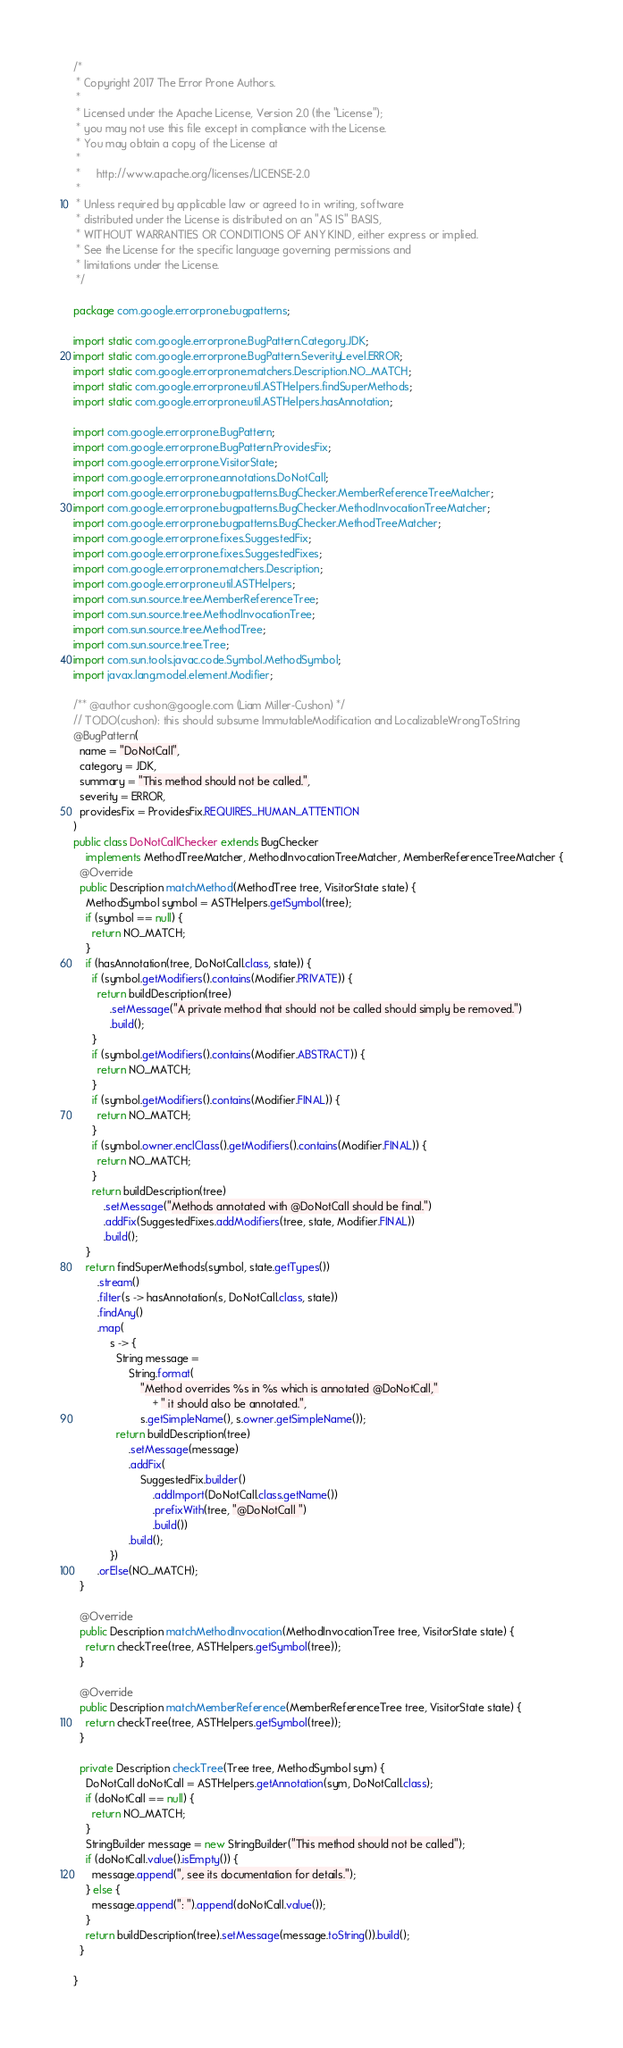Convert code to text. <code><loc_0><loc_0><loc_500><loc_500><_Java_>/*
 * Copyright 2017 The Error Prone Authors.
 *
 * Licensed under the Apache License, Version 2.0 (the "License");
 * you may not use this file except in compliance with the License.
 * You may obtain a copy of the License at
 *
 *     http://www.apache.org/licenses/LICENSE-2.0
 *
 * Unless required by applicable law or agreed to in writing, software
 * distributed under the License is distributed on an "AS IS" BASIS,
 * WITHOUT WARRANTIES OR CONDITIONS OF ANY KIND, either express or implied.
 * See the License for the specific language governing permissions and
 * limitations under the License.
 */

package com.google.errorprone.bugpatterns;

import static com.google.errorprone.BugPattern.Category.JDK;
import static com.google.errorprone.BugPattern.SeverityLevel.ERROR;
import static com.google.errorprone.matchers.Description.NO_MATCH;
import static com.google.errorprone.util.ASTHelpers.findSuperMethods;
import static com.google.errorprone.util.ASTHelpers.hasAnnotation;

import com.google.errorprone.BugPattern;
import com.google.errorprone.BugPattern.ProvidesFix;
import com.google.errorprone.VisitorState;
import com.google.errorprone.annotations.DoNotCall;
import com.google.errorprone.bugpatterns.BugChecker.MemberReferenceTreeMatcher;
import com.google.errorprone.bugpatterns.BugChecker.MethodInvocationTreeMatcher;
import com.google.errorprone.bugpatterns.BugChecker.MethodTreeMatcher;
import com.google.errorprone.fixes.SuggestedFix;
import com.google.errorprone.fixes.SuggestedFixes;
import com.google.errorprone.matchers.Description;
import com.google.errorprone.util.ASTHelpers;
import com.sun.source.tree.MemberReferenceTree;
import com.sun.source.tree.MethodInvocationTree;
import com.sun.source.tree.MethodTree;
import com.sun.source.tree.Tree;
import com.sun.tools.javac.code.Symbol.MethodSymbol;
import javax.lang.model.element.Modifier;

/** @author cushon@google.com (Liam Miller-Cushon) */
// TODO(cushon): this should subsume ImmutableModification and LocalizableWrongToString
@BugPattern(
  name = "DoNotCall",
  category = JDK,
  summary = "This method should not be called.",
  severity = ERROR,
  providesFix = ProvidesFix.REQUIRES_HUMAN_ATTENTION
)
public class DoNotCallChecker extends BugChecker
    implements MethodTreeMatcher, MethodInvocationTreeMatcher, MemberReferenceTreeMatcher {
  @Override
  public Description matchMethod(MethodTree tree, VisitorState state) {
    MethodSymbol symbol = ASTHelpers.getSymbol(tree);
    if (symbol == null) {
      return NO_MATCH;
    }
    if (hasAnnotation(tree, DoNotCall.class, state)) {
      if (symbol.getModifiers().contains(Modifier.PRIVATE)) {
        return buildDescription(tree)
            .setMessage("A private method that should not be called should simply be removed.")
            .build();
      }
      if (symbol.getModifiers().contains(Modifier.ABSTRACT)) {
        return NO_MATCH;
      }
      if (symbol.getModifiers().contains(Modifier.FINAL)) {
        return NO_MATCH;
      }
      if (symbol.owner.enclClass().getModifiers().contains(Modifier.FINAL)) {
        return NO_MATCH;
      }
      return buildDescription(tree)
          .setMessage("Methods annotated with @DoNotCall should be final.")
          .addFix(SuggestedFixes.addModifiers(tree, state, Modifier.FINAL))
          .build();
    }
    return findSuperMethods(symbol, state.getTypes())
        .stream()
        .filter(s -> hasAnnotation(s, DoNotCall.class, state))
        .findAny()
        .map(
            s -> {
              String message =
                  String.format(
                      "Method overrides %s in %s which is annotated @DoNotCall,"
                          + " it should also be annotated.",
                      s.getSimpleName(), s.owner.getSimpleName());
              return buildDescription(tree)
                  .setMessage(message)
                  .addFix(
                      SuggestedFix.builder()
                          .addImport(DoNotCall.class.getName())
                          .prefixWith(tree, "@DoNotCall ")
                          .build())
                  .build();
            })
        .orElse(NO_MATCH);
  }

  @Override
  public Description matchMethodInvocation(MethodInvocationTree tree, VisitorState state) {
    return checkTree(tree, ASTHelpers.getSymbol(tree));
  }

  @Override
  public Description matchMemberReference(MemberReferenceTree tree, VisitorState state) {
    return checkTree(tree, ASTHelpers.getSymbol(tree));
  }

  private Description checkTree(Tree tree, MethodSymbol sym) {
    DoNotCall doNotCall = ASTHelpers.getAnnotation(sym, DoNotCall.class);
    if (doNotCall == null) {
      return NO_MATCH;
    }
    StringBuilder message = new StringBuilder("This method should not be called");
    if (doNotCall.value().isEmpty()) {
      message.append(", see its documentation for details.");
    } else {
      message.append(": ").append(doNotCall.value());
    }
    return buildDescription(tree).setMessage(message.toString()).build();
  }

}
</code> 